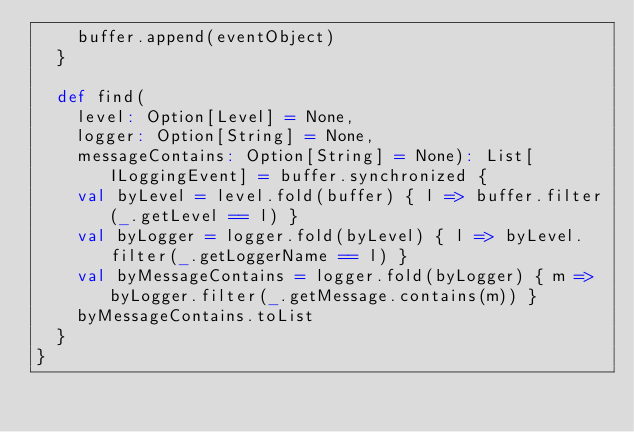Convert code to text. <code><loc_0><loc_0><loc_500><loc_500><_Scala_>    buffer.append(eventObject)
  }

  def find(
    level: Option[Level] = None,
    logger: Option[String] = None,
    messageContains: Option[String] = None): List[ILoggingEvent] = buffer.synchronized {
    val byLevel = level.fold(buffer) { l => buffer.filter(_.getLevel == l) }
    val byLogger = logger.fold(byLevel) { l => byLevel.filter(_.getLoggerName == l) }
    val byMessageContains = logger.fold(byLogger) { m => byLogger.filter(_.getMessage.contains(m)) }
    byMessageContains.toList
  }
}
</code> 